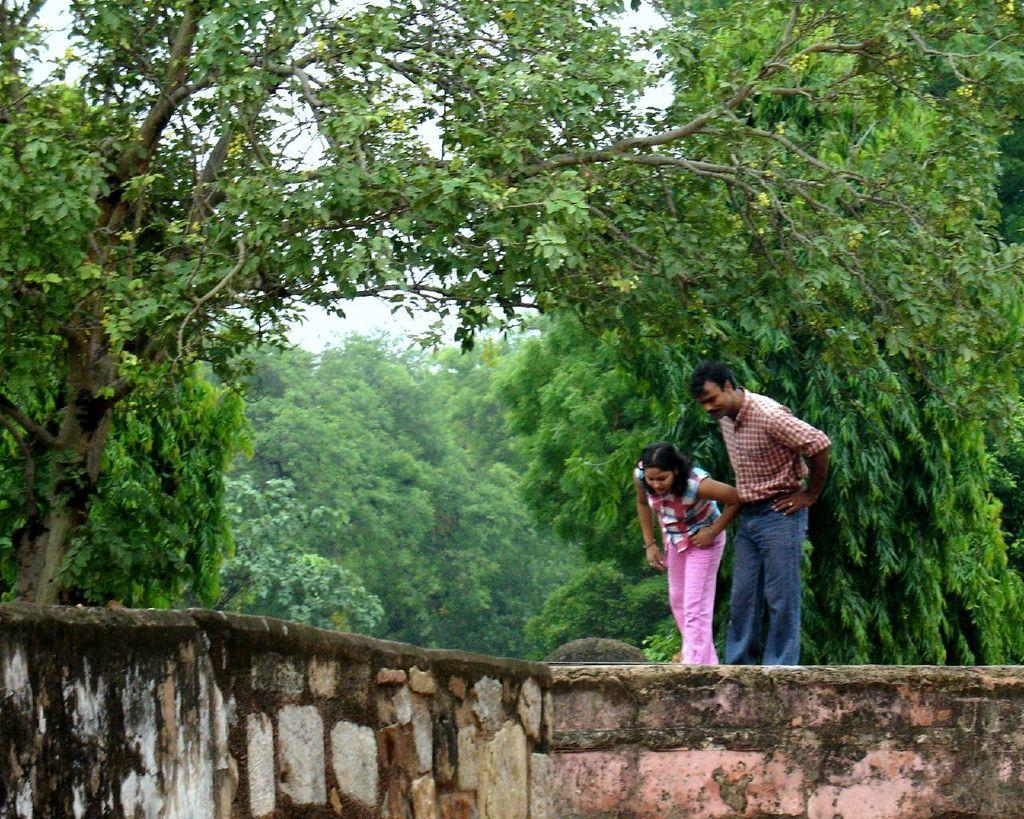What are the two people in the image doing? The two people are standing on a wall in the image. What can be seen in the background of the image? There are many trees visible in the image. How many cherries are on the chessboard in the image? There is no chessboard or cherries present in the image. What finger is the person on the left using to point at the tree? There is no person pointing at a tree in the image. 